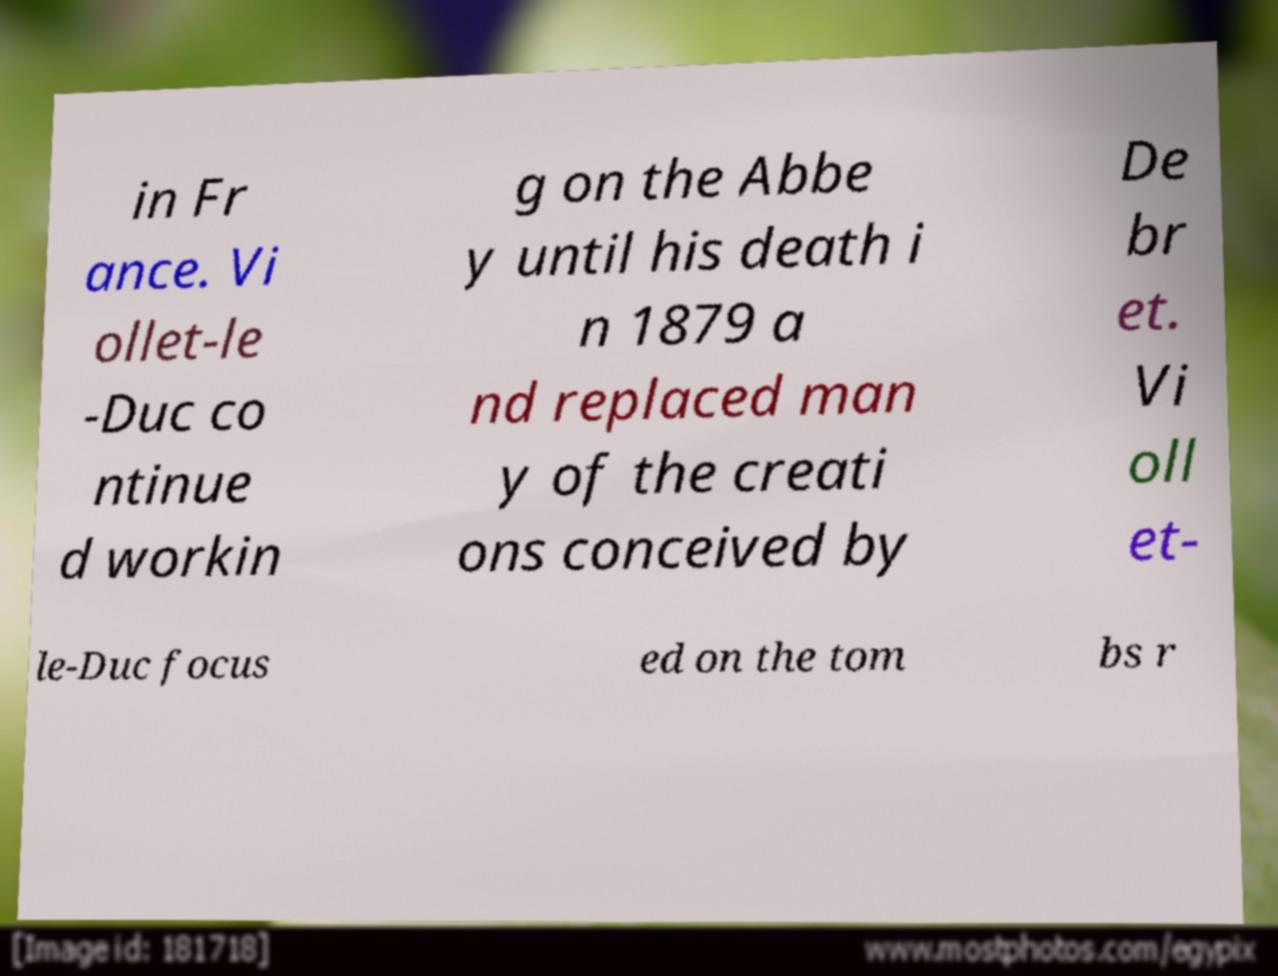Can you read and provide the text displayed in the image?This photo seems to have some interesting text. Can you extract and type it out for me? in Fr ance. Vi ollet-le -Duc co ntinue d workin g on the Abbe y until his death i n 1879 a nd replaced man y of the creati ons conceived by De br et. Vi oll et- le-Duc focus ed on the tom bs r 